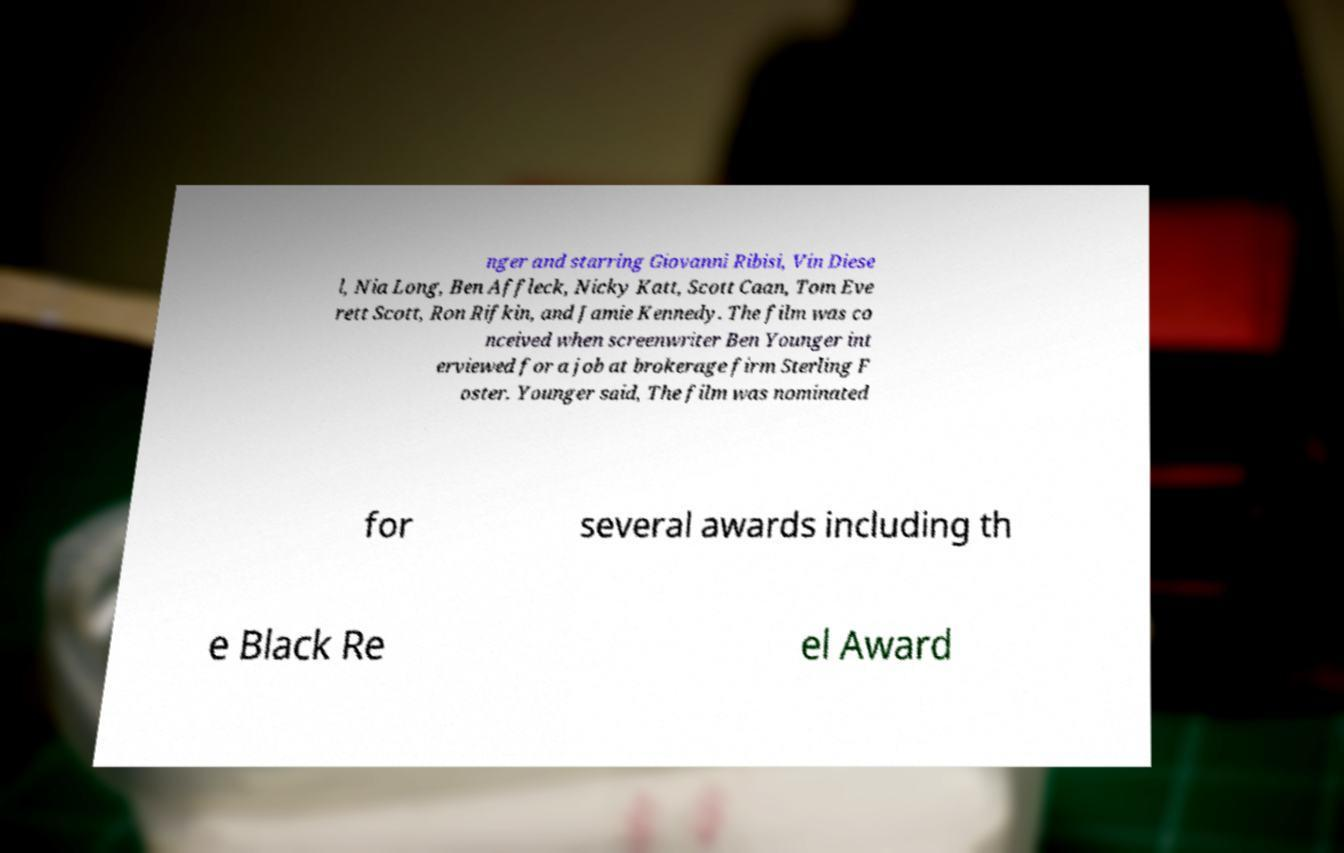Please identify and transcribe the text found in this image. nger and starring Giovanni Ribisi, Vin Diese l, Nia Long, Ben Affleck, Nicky Katt, Scott Caan, Tom Eve rett Scott, Ron Rifkin, and Jamie Kennedy. The film was co nceived when screenwriter Ben Younger int erviewed for a job at brokerage firm Sterling F oster. Younger said, The film was nominated for several awards including th e Black Re el Award 